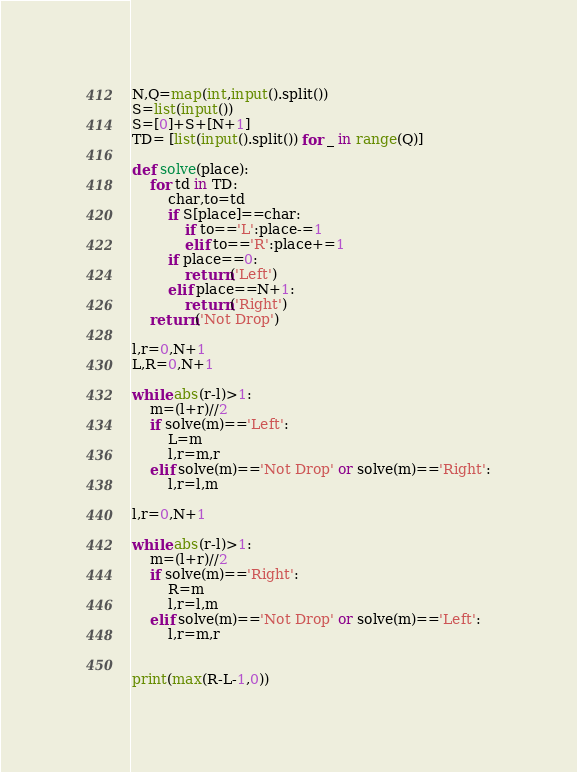Convert code to text. <code><loc_0><loc_0><loc_500><loc_500><_Python_>N,Q=map(int,input().split())
S=list(input())
S=[0]+S+[N+1]
TD= [list(input().split()) for _ in range(Q)]

def solve(place):
    for td in TD:
        char,to=td
        if S[place]==char:
            if to=='L':place-=1
            elif to=='R':place+=1
        if place==0:
            return('Left')
        elif place==N+1:
            return('Right')
    return('Not Drop')

l,r=0,N+1
L,R=0,N+1

while abs(r-l)>1:
    m=(l+r)//2
    if solve(m)=='Left':
        L=m
        l,r=m,r
    elif solve(m)=='Not Drop' or solve(m)=='Right':
        l,r=l,m

l,r=0,N+1

while abs(r-l)>1:
    m=(l+r)//2
    if solve(m)=='Right':
        R=m
        l,r=l,m
    elif solve(m)=='Not Drop' or solve(m)=='Left':
        l,r=m,r


print(max(R-L-1,0))
</code> 